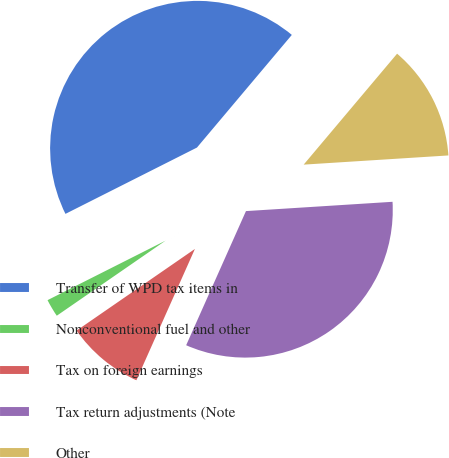Convert chart. <chart><loc_0><loc_0><loc_500><loc_500><pie_chart><fcel>Transfer of WPD tax items in<fcel>Nonconventional fuel and other<fcel>Tax on foreign earnings<fcel>Tax return adjustments (Note<fcel>Other<nl><fcel>43.57%<fcel>2.18%<fcel>8.71%<fcel>32.68%<fcel>12.85%<nl></chart> 